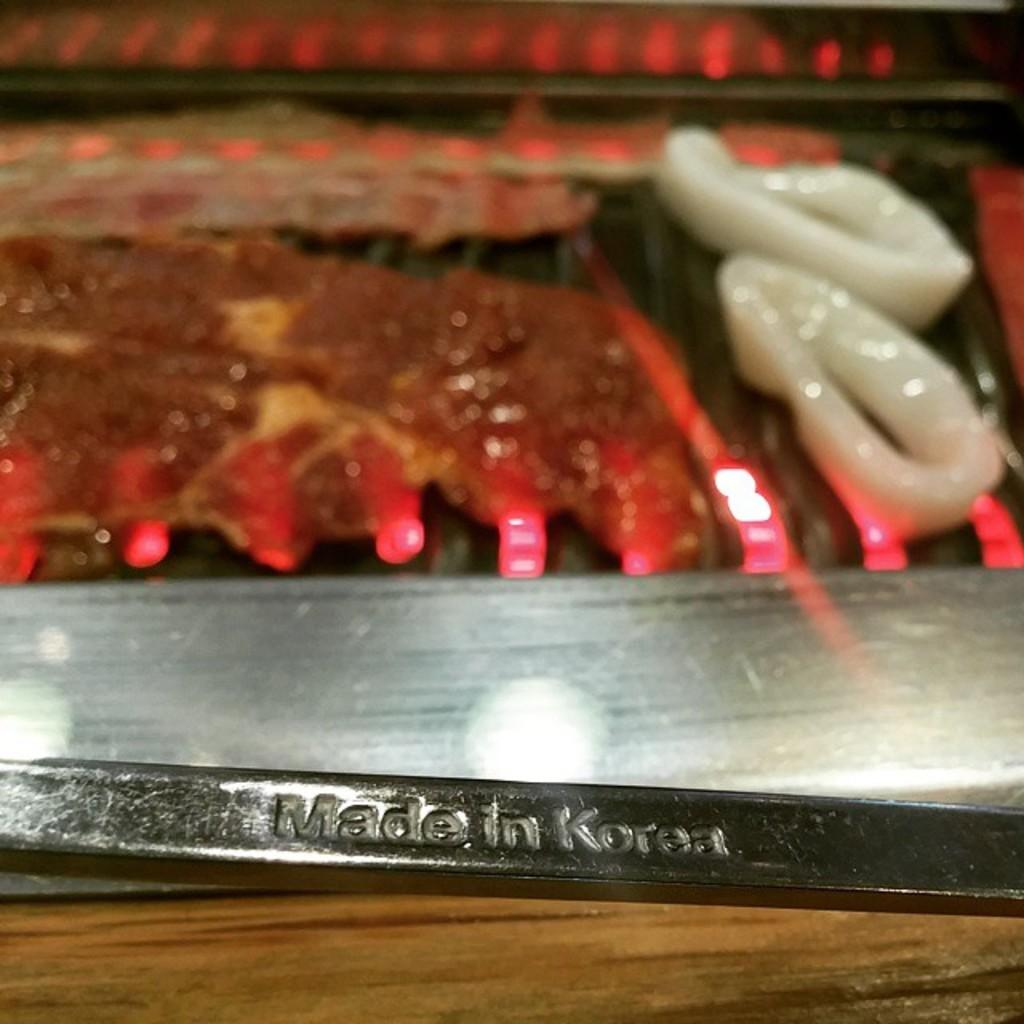What is the main object in the center of the image? There is a grill in the center of the image. What is happening to the food in the image? Food is present on the grill. Can you describe any other objects in the image? There is a rod at the bottom of the image. How many ducks are swimming in the water near the grill in the image? There are no ducks present in the image; it only features a grill with food and a rod. 